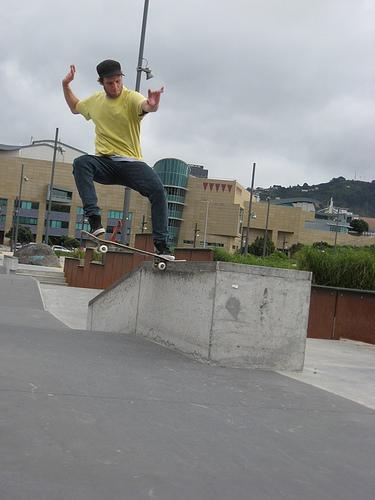What kind of trick is this skateboarder performing? Please explain your reasoning. tail slide. The skateboarder is performing a slide with the tail of the skateboard. 